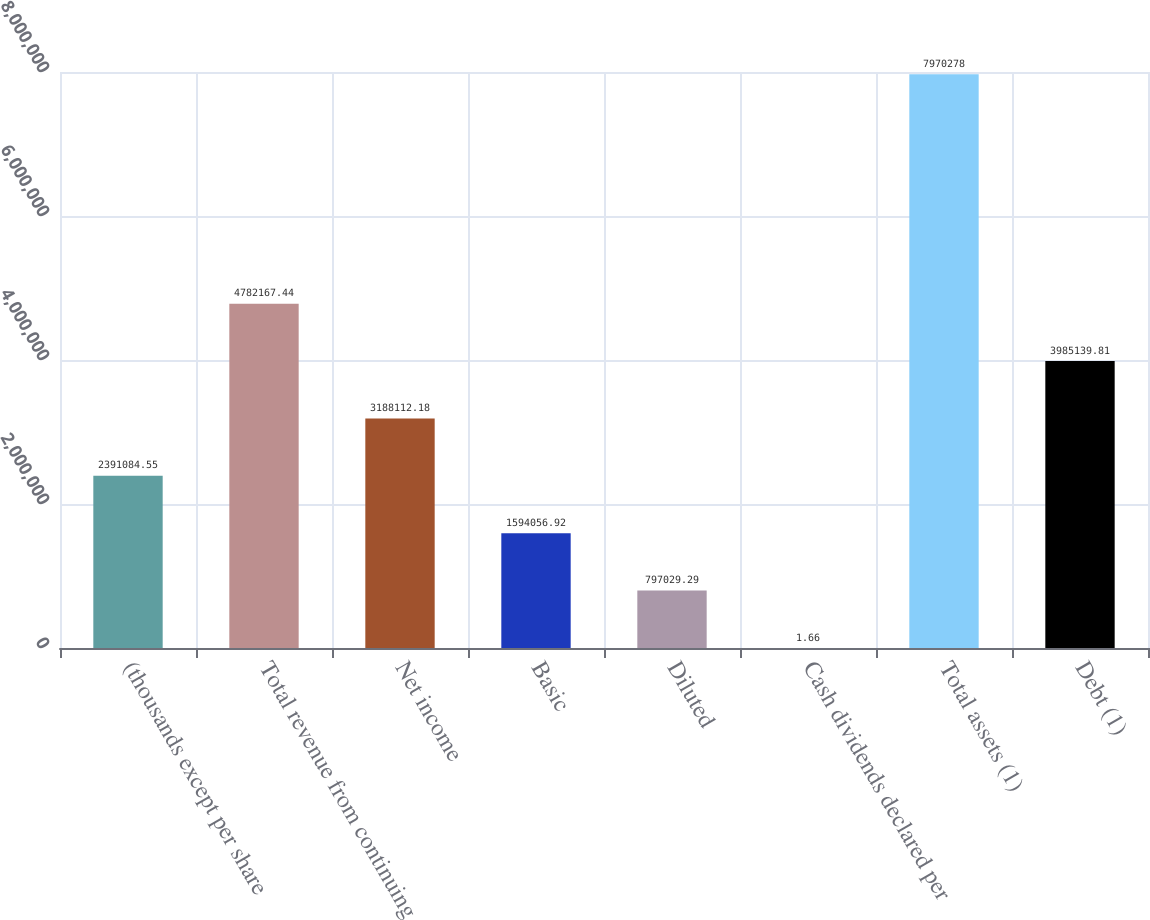Convert chart. <chart><loc_0><loc_0><loc_500><loc_500><bar_chart><fcel>(thousands except per share<fcel>Total revenue from continuing<fcel>Net income<fcel>Basic<fcel>Diluted<fcel>Cash dividends declared per<fcel>Total assets (1)<fcel>Debt (1)<nl><fcel>2.39108e+06<fcel>4.78217e+06<fcel>3.18811e+06<fcel>1.59406e+06<fcel>797029<fcel>1.66<fcel>7.97028e+06<fcel>3.98514e+06<nl></chart> 